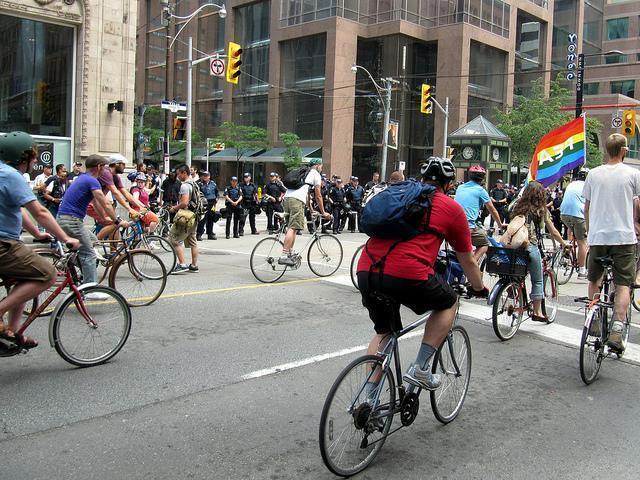Why are the men in uniforms standing by the road?
Select the accurate response from the four choices given to answer the question.
Options: Street workers, entertainment, doctors, security. Security. 